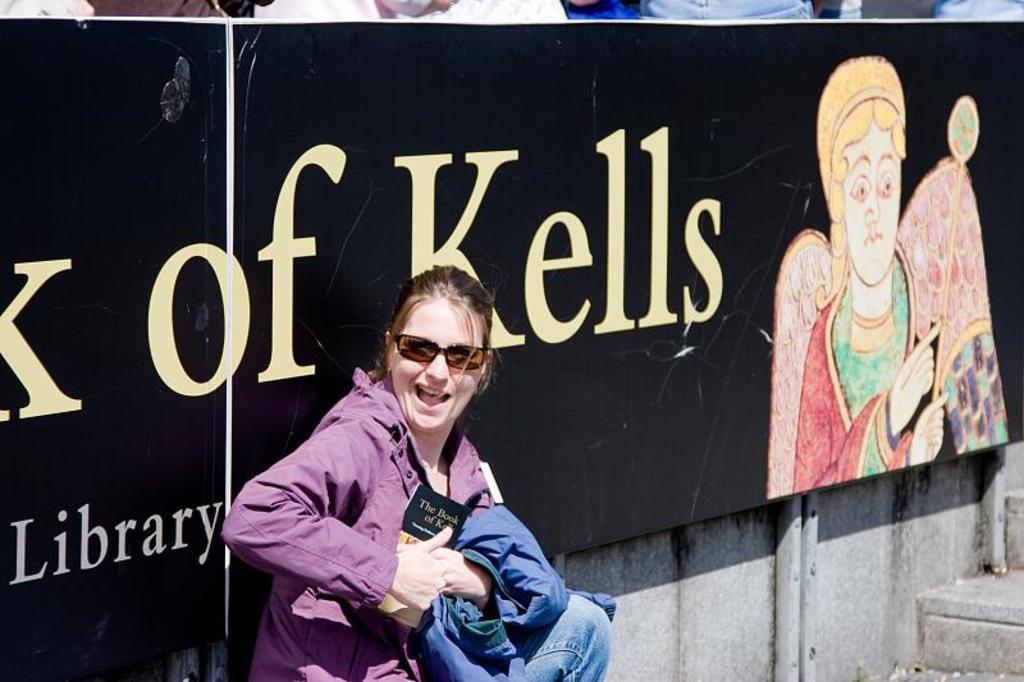Please provide a concise description of this image. In this image there is a woman with a smile on her face is holding a jacket and a book in her hands, behind the woman there is a board. 